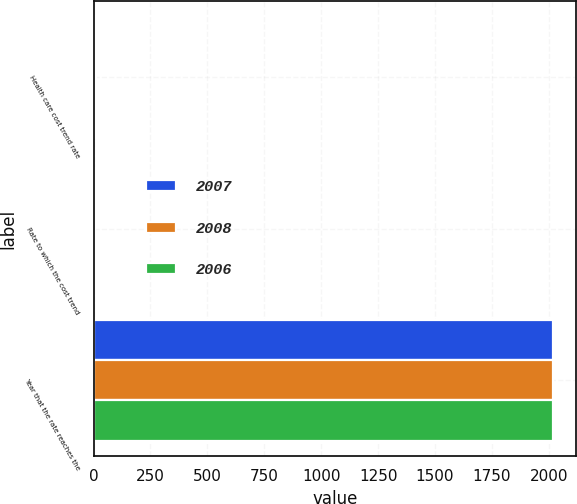<chart> <loc_0><loc_0><loc_500><loc_500><stacked_bar_chart><ecel><fcel>Health care cost trend rate<fcel>Rate to which the cost trend<fcel>Year that the rate reaches the<nl><fcel>2007<fcel>8.91<fcel>4.52<fcel>2017<nl><fcel>2008<fcel>9.37<fcel>4.49<fcel>2018<nl><fcel>2006<fcel>9.87<fcel>4.49<fcel>2018<nl></chart> 